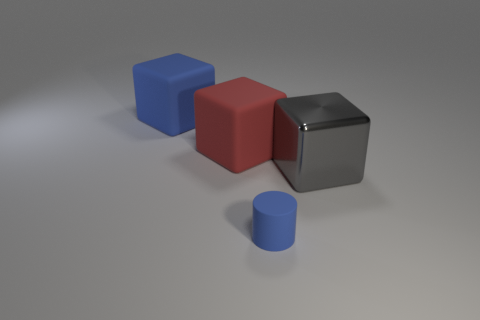Add 4 tiny blue matte cylinders. How many objects exist? 8 Subtract all blocks. How many objects are left? 1 Subtract 0 green balls. How many objects are left? 4 Subtract all blue metallic objects. Subtract all big gray metallic blocks. How many objects are left? 3 Add 2 red rubber objects. How many red rubber objects are left? 3 Add 3 large gray metallic objects. How many large gray metallic objects exist? 4 